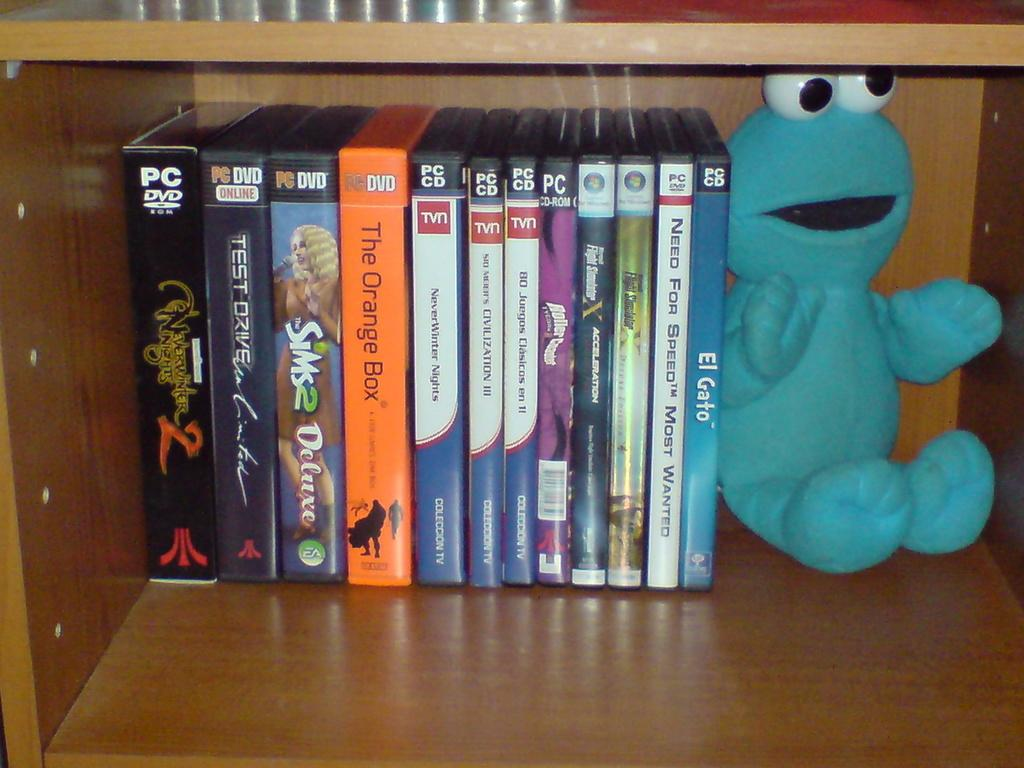Provide a one-sentence caption for the provided image. Several cases for discs including the Sims 2 Deluxe and El Gato are lined up neatly on a bookshelf. 